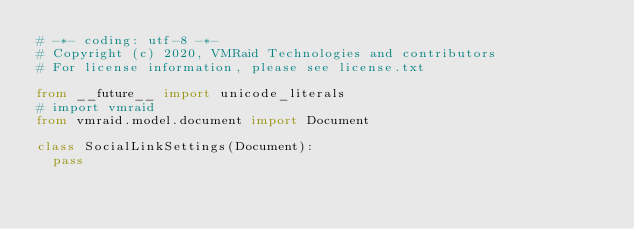Convert code to text. <code><loc_0><loc_0><loc_500><loc_500><_Python_># -*- coding: utf-8 -*-
# Copyright (c) 2020, VMRaid Technologies and contributors
# For license information, please see license.txt

from __future__ import unicode_literals
# import vmraid
from vmraid.model.document import Document

class SocialLinkSettings(Document):
	pass
</code> 